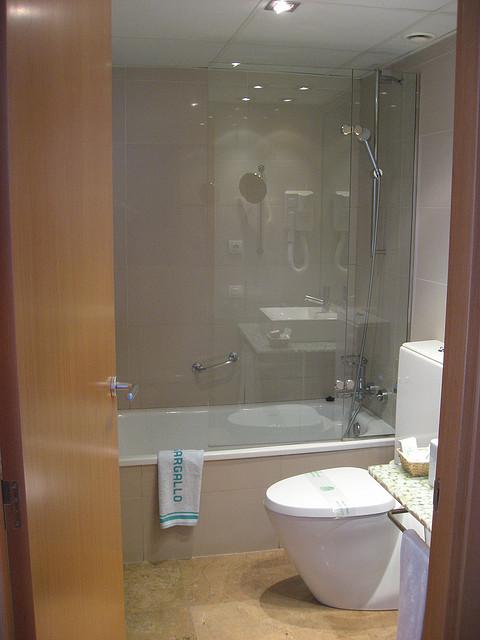Is anyone in the shower?
Keep it brief. No. What color is the towel?
Be succinct. White. Have the towels been used?
Give a very brief answer. No. Is this a bathroom?
Write a very short answer. Yes. 